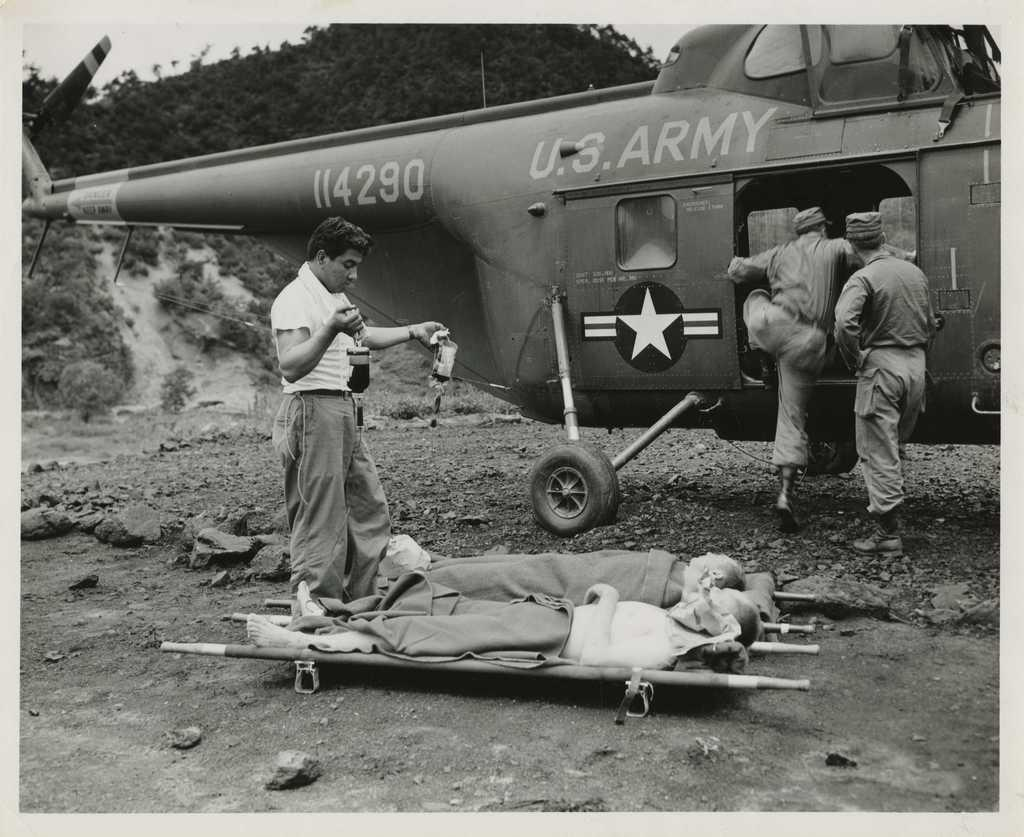<image>
Give a short and clear explanation of the subsequent image. An army plane with the numbers 4290 on the side. 